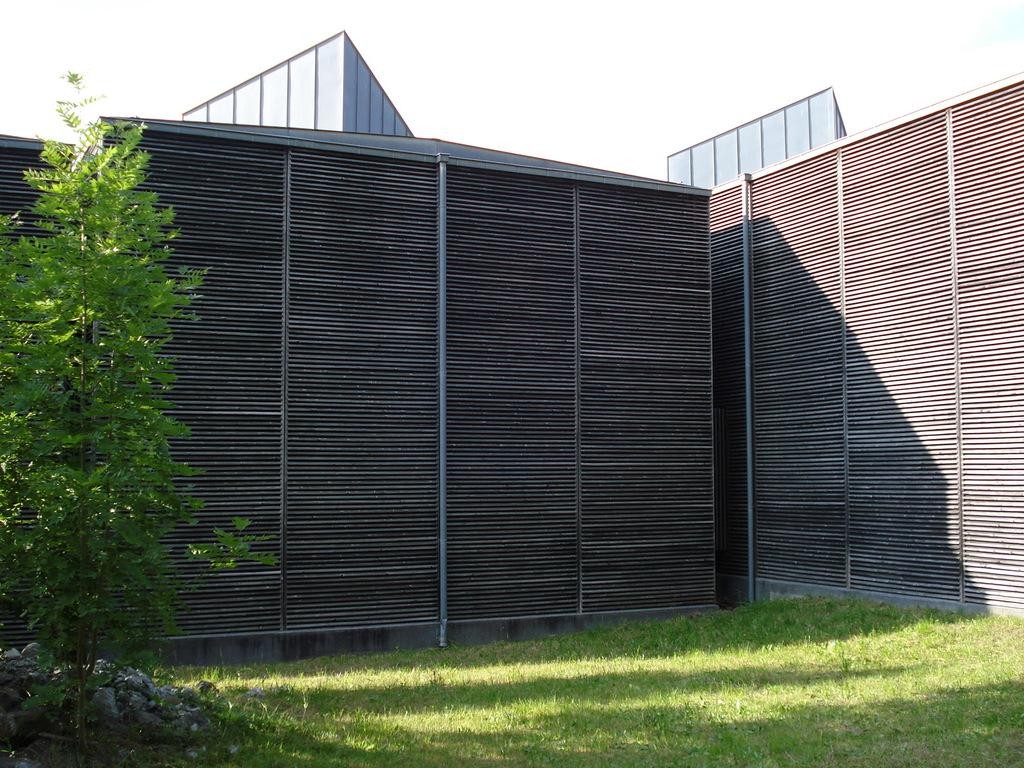What type of barrier can be seen in the image? There is a fence in the image. What type of vegetation is present in the image? There is a plant and grass in the image. What type of ground cover is visible in the image? There are stones in the image. What is visible in the background of the image? The sky is visible in the image. Can you see a guitar being played in the image? There is no guitar or anyone playing a guitar in the image. Is there a volleyball game happening in the image? There is no volleyball or any indication of a game in the image. 